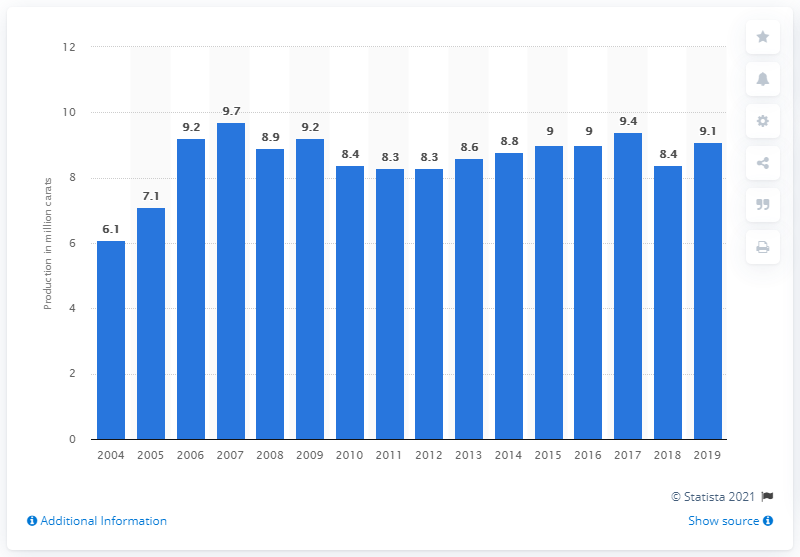Indicate a few pertinent items in this graphic. Angola's diamond production volume in 2019 was 9.1 million carats. The production volume of diamonds in Angola in 2004 was 6.1 million carats. 